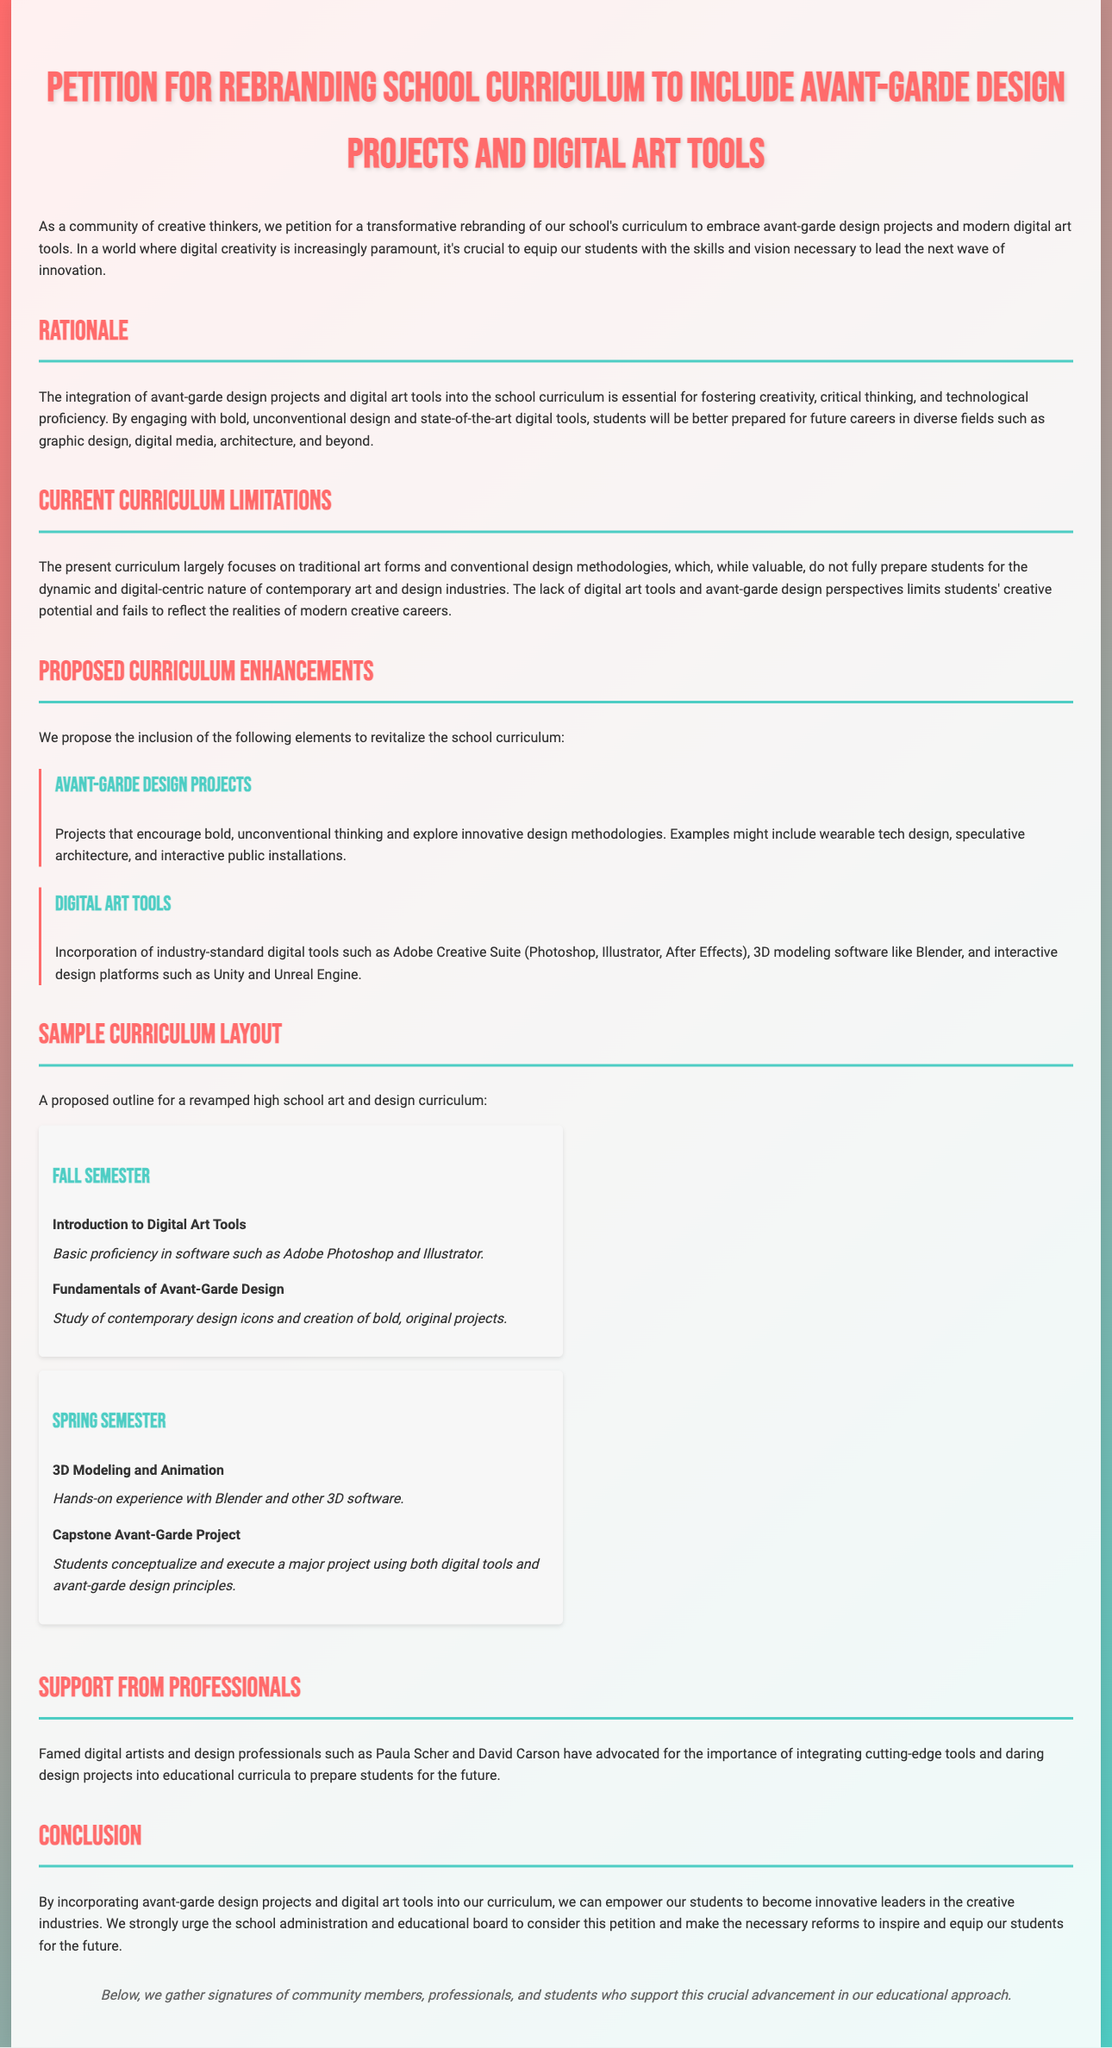what is the title of the petition? The title of the petition is displayed prominently at the top of the document.
Answer: Petition for Rebranding School Curriculum to Include Avant-Garde Design Projects and Digital Art Tools what is the main goal of the petition? The main goal of the petition is articulated in the introductory paragraphs and highlights the desired curriculum changes.
Answer: To embrace avant-garde design projects and modern digital art tools who are some professionals mentioned in support of the petition? The document specifically lists renowned professionals who advocate for the proposed curriculum changes.
Answer: Paula Scher and David Carson how many semesters are proposed in the sample curriculum layout? The content outlines a curriculum layout that includes details for two semesters.
Answer: Two what software is mentioned for digital art tools? The document indicates specific software that should be incorporated as part of the curriculum enhancements.
Answer: Adobe Creative Suite what type of project is suggested as a capstone? The details of the capstone project are specified in the spring semester section of the curriculum layout.
Answer: Capstone Avant-Garde Project what is the design methodology focus of the current curriculum? The petition outlines the limitations of the existing curriculum, particularly in its design approach.
Answer: Traditional art forms how does the petition aim to prepare students? The rationale section explains the intended outcomes for students through the proposed changes in the curriculum.
Answer: For future careers in diverse fields 